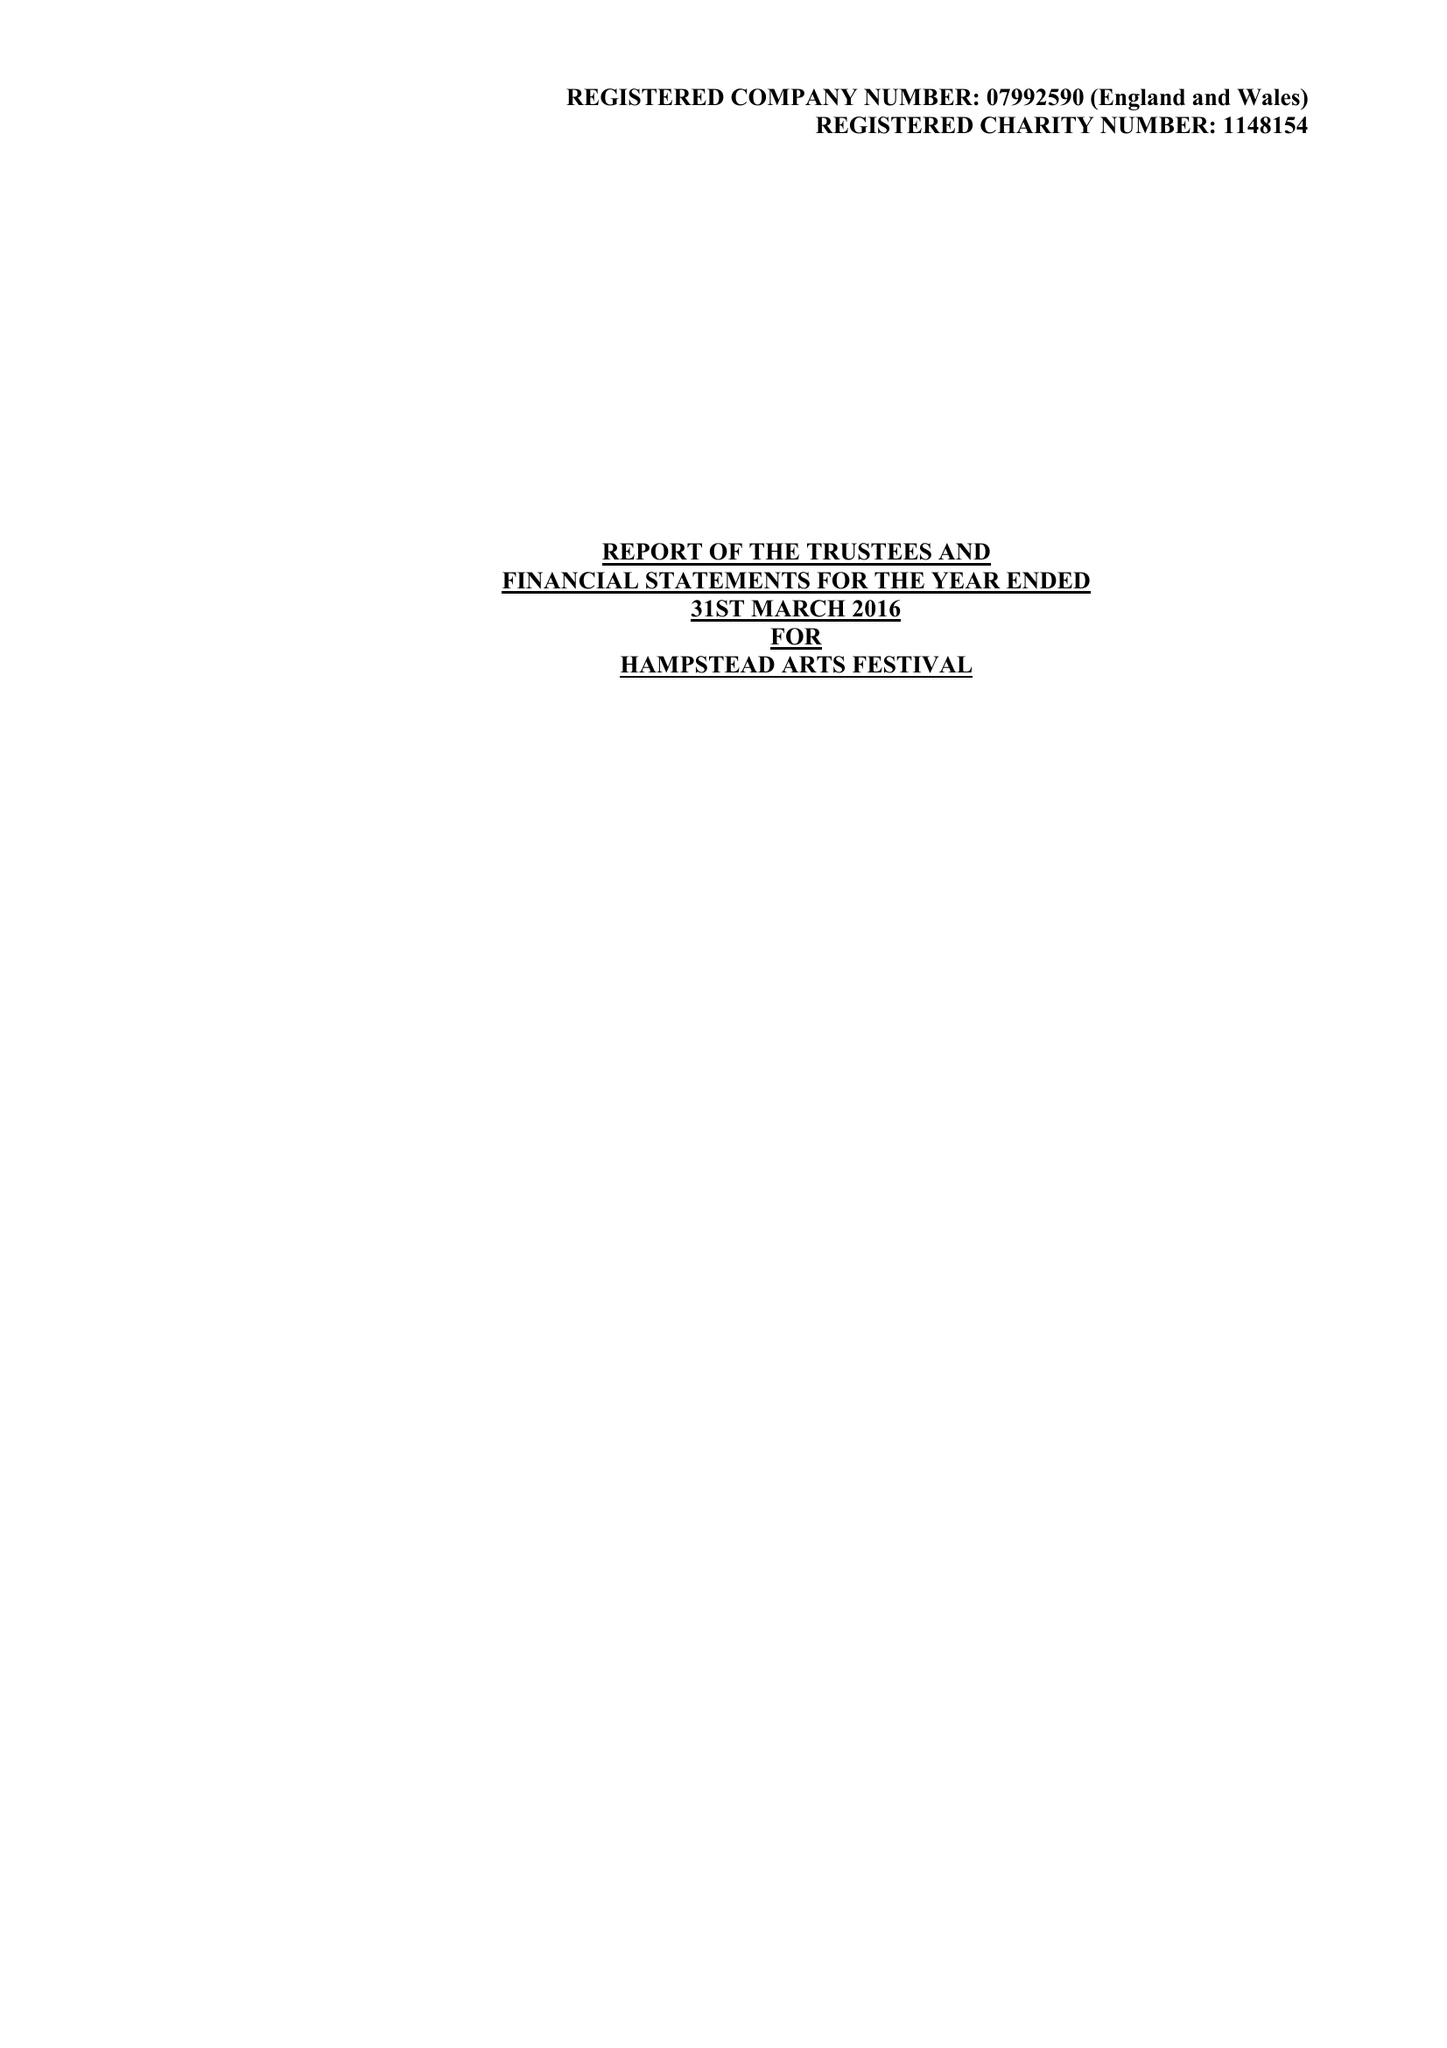What is the value for the income_annually_in_british_pounds?
Answer the question using a single word or phrase. 59662.00 